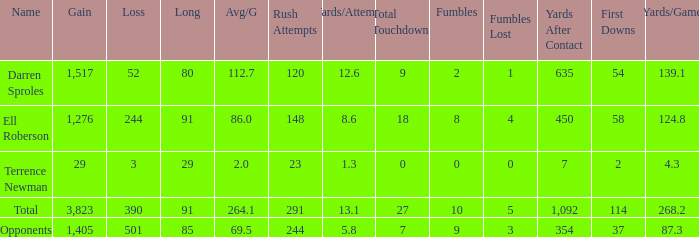Calculate the sum of average yards gained when the gained yards is below 1,276 and the loss exceeds 3 yards. None. 